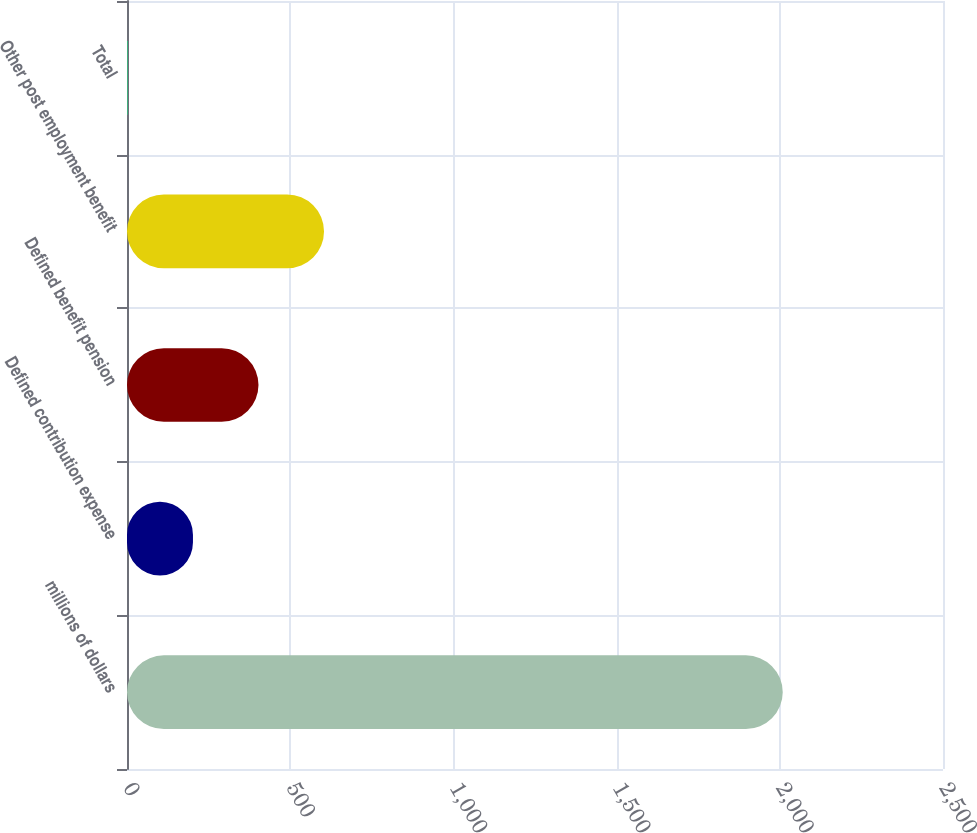Convert chart to OTSL. <chart><loc_0><loc_0><loc_500><loc_500><bar_chart><fcel>millions of dollars<fcel>Defined contribution expense<fcel>Defined benefit pension<fcel>Other post employment benefit<fcel>Total<nl><fcel>2009<fcel>202.07<fcel>402.84<fcel>603.61<fcel>1.3<nl></chart> 